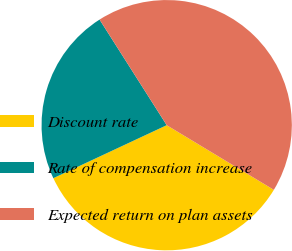<chart> <loc_0><loc_0><loc_500><loc_500><pie_chart><fcel>Discount rate<fcel>Rate of compensation increase<fcel>Expected return on plan assets<nl><fcel>34.4%<fcel>22.95%<fcel>42.66%<nl></chart> 